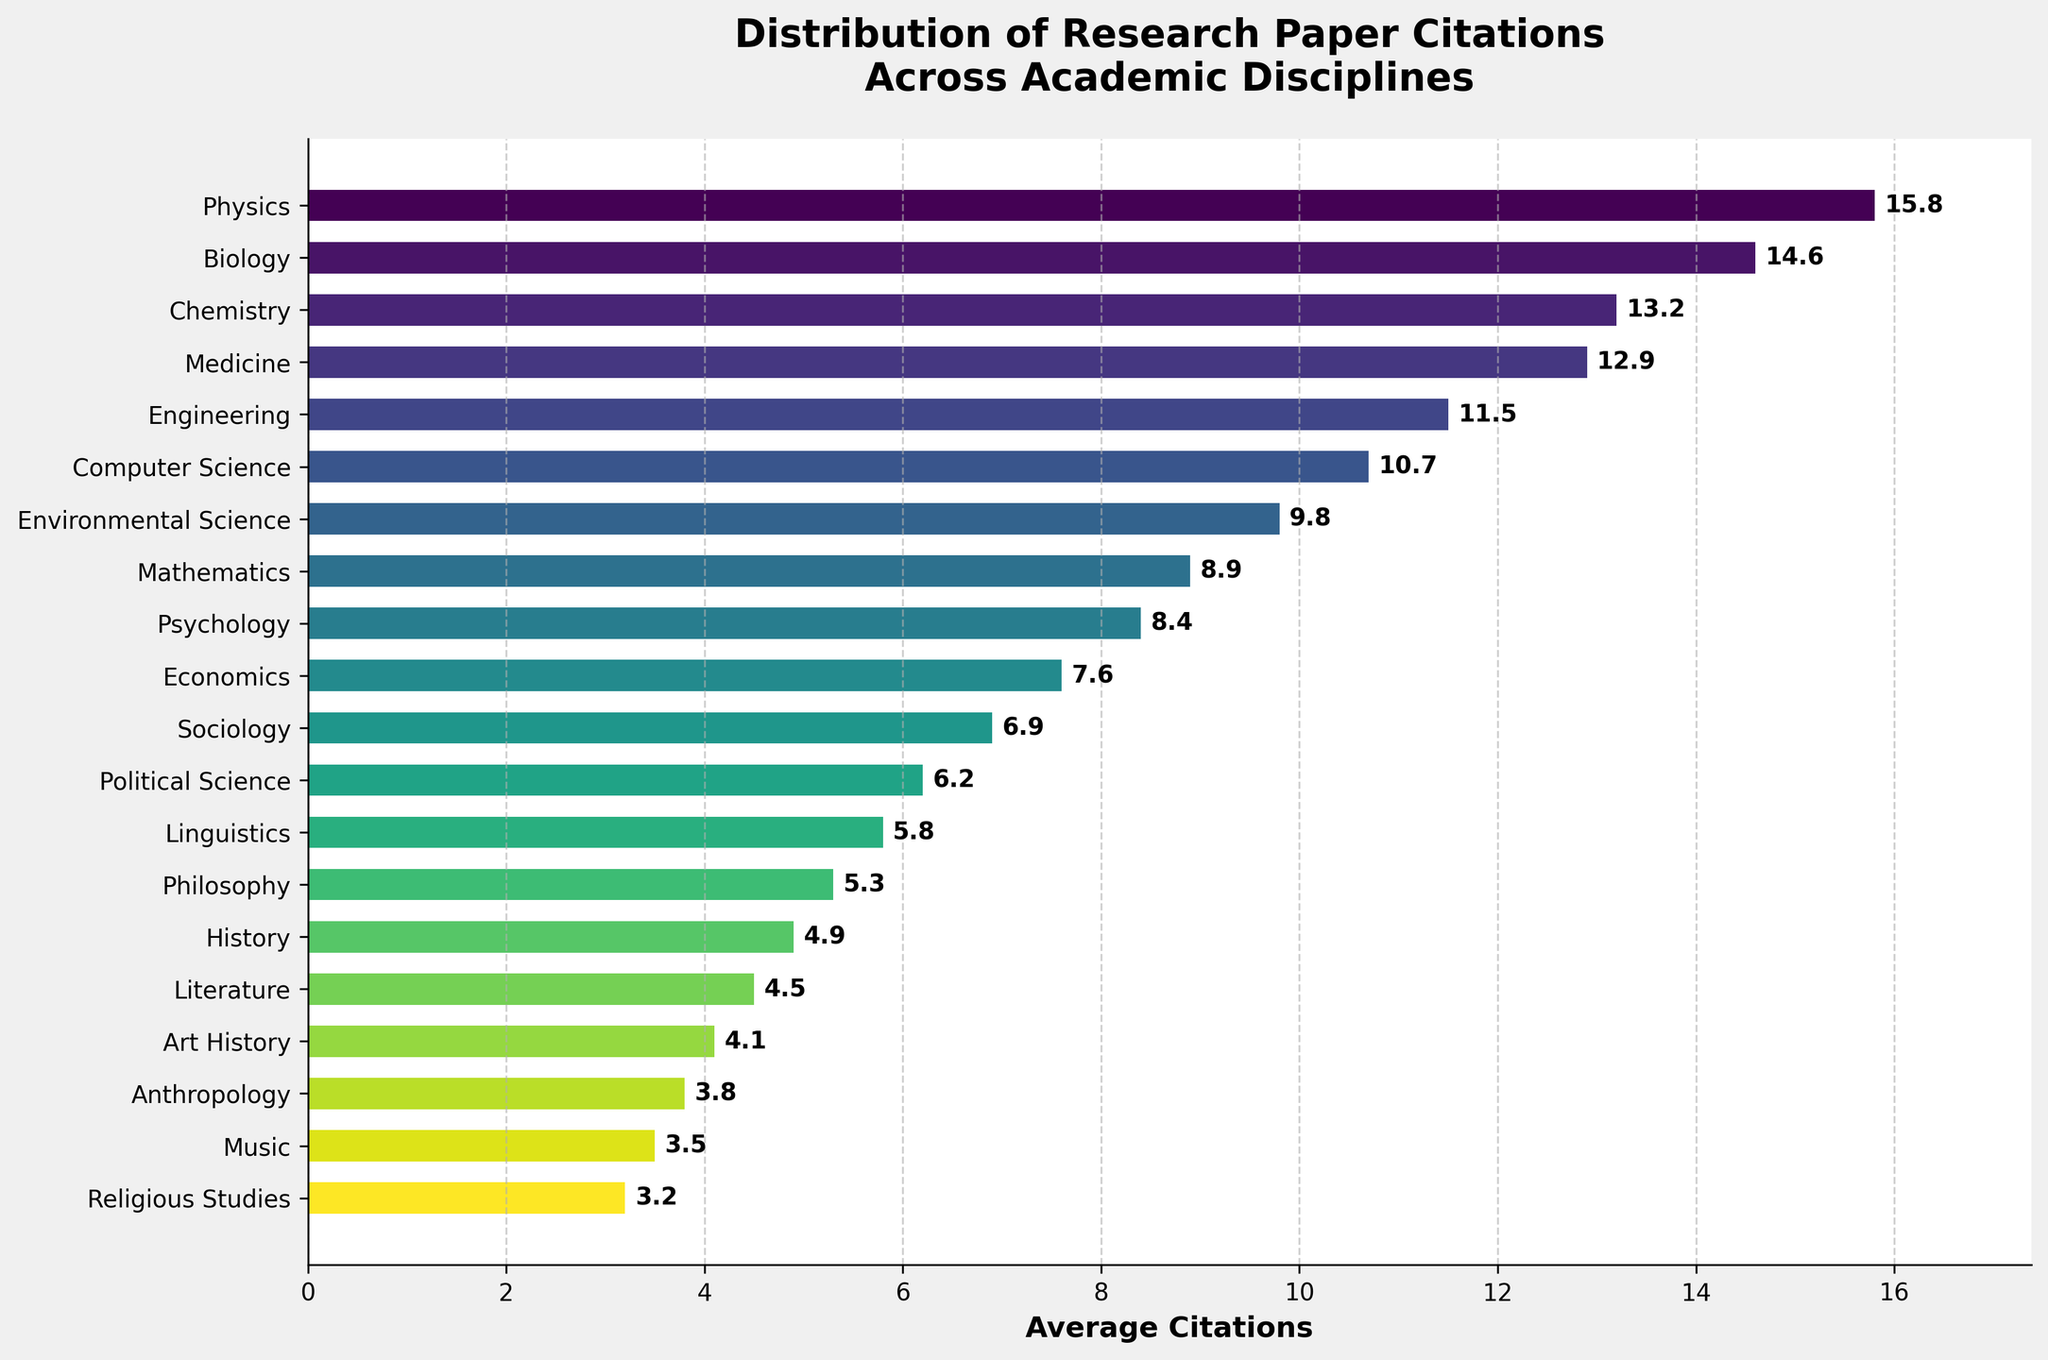What discipline has the highest average number of citations? Look at the bar chart and find the bar that reaches the farthest to the right, which corresponds to Physics with 15.8 average citations.
Answer: Physics Which discipline has the lowest average number of citations? Look at the bar chart and find the bar that is the shortest, which corresponds to Religious Studies with 3.2 average citations.
Answer: Religious Studies What is the difference in average citations between Psychology and Economics? From the chart, Psychology has 8.4 average citations, and Economics has 7.6. Subtract 7.6 from 8.4 to get the difference.
Answer: 0.8 Which discipline has average citations closest to the median of all disciplines? Arrange the citation values in ascending order and find the median. Psychology with 8.4 average citations is the closest to the median.
Answer: Psychology Of the disciplines with more than 10 average citations, which has the fewest? Identify the disciplines with more than 10 average citations: Physics, Biology, Chemistry, Medicine, and Engineering; Engineering has the fewest with 11.5.
Answer: Engineering How many disciplines have an average citation of more than 10? Count the number of bars that extend past the 10 mark on the x-axis; there are five (Physics, Biology, Chemistry, Medicine, and Engineering).
Answer: 5 How many disciplines have fewer average citations than Mathematics? Find Mathematics, which is at 8.9 citations, and count all bars that are shorter; there are eleven disciplines.
Answer: 11 What is the combined average citation of the top three disciplines? Sum the average citations of Physics (15.8), Biology (14.6), and Chemistry (13.2): 15.8 + 14.6 + 13.2 = 43.6
Answer: 43.6 Are there more disciplines with fewer than 6 citations or more than 10 citations? Count disciplines fewer than 6 (five: Sociology, Political Science, Linguistics, Philosophy, History, Literature, Art History, Anthropology, Music, and Religious Studies) and those with more than 10 (five: Physics, Biology, Chemistry, Medicine, Engineering). There are more with fewer than 6.
Answer: More with fewer than 6 